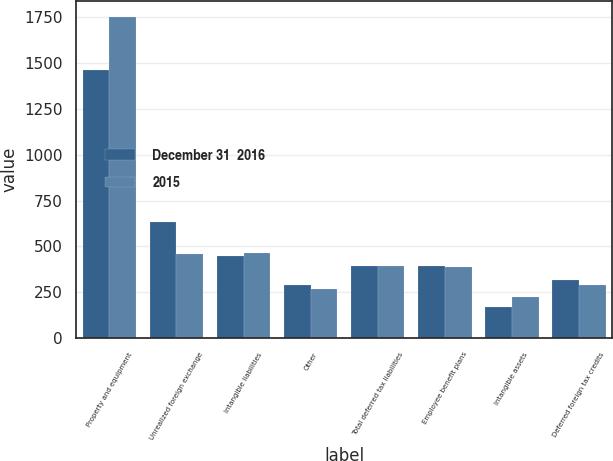Convert chart. <chart><loc_0><loc_0><loc_500><loc_500><stacked_bar_chart><ecel><fcel>Property and equipment<fcel>Unrealized foreign exchange<fcel>Intangible liabilities<fcel>Other<fcel>Total deferred tax liabilities<fcel>Employee benefit plans<fcel>Intangible assets<fcel>Deferred foreign tax credits<nl><fcel>December 31  2016<fcel>1459.8<fcel>630.9<fcel>445.2<fcel>287.6<fcel>392.55<fcel>395<fcel>170.7<fcel>316.8<nl><fcel>2015<fcel>1751.7<fcel>455.6<fcel>464.7<fcel>268.5<fcel>392.55<fcel>390.1<fcel>222.6<fcel>289.2<nl></chart> 